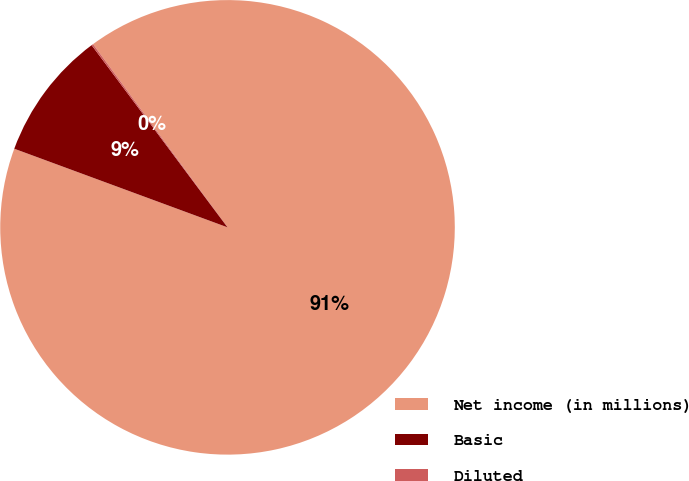Convert chart. <chart><loc_0><loc_0><loc_500><loc_500><pie_chart><fcel>Net income (in millions)<fcel>Basic<fcel>Diluted<nl><fcel>90.7%<fcel>9.18%<fcel>0.12%<nl></chart> 